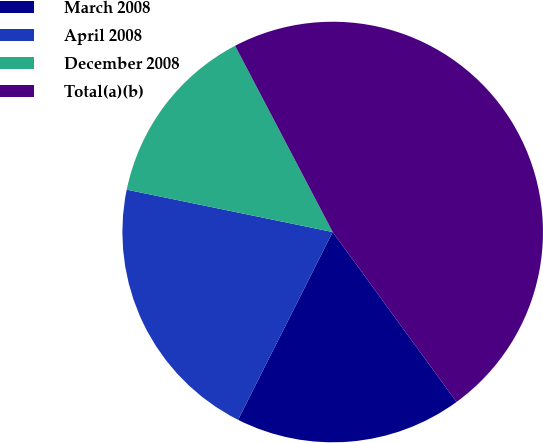Convert chart to OTSL. <chart><loc_0><loc_0><loc_500><loc_500><pie_chart><fcel>March 2008<fcel>April 2008<fcel>December 2008<fcel>Total(a)(b)<nl><fcel>17.45%<fcel>20.8%<fcel>14.09%<fcel>47.66%<nl></chart> 